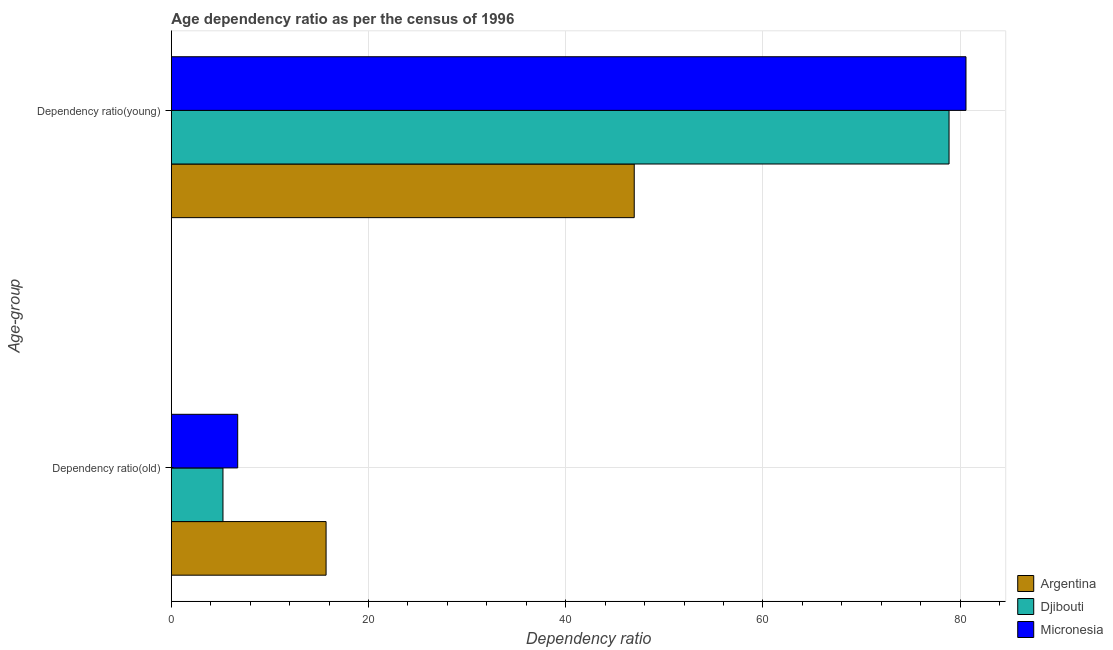How many different coloured bars are there?
Give a very brief answer. 3. Are the number of bars per tick equal to the number of legend labels?
Your response must be concise. Yes. Are the number of bars on each tick of the Y-axis equal?
Provide a short and direct response. Yes. How many bars are there on the 2nd tick from the top?
Keep it short and to the point. 3. How many bars are there on the 2nd tick from the bottom?
Provide a short and direct response. 3. What is the label of the 1st group of bars from the top?
Provide a succinct answer. Dependency ratio(young). What is the age dependency ratio(old) in Djibouti?
Provide a succinct answer. 5.23. Across all countries, what is the maximum age dependency ratio(young)?
Offer a very short reply. 80.6. Across all countries, what is the minimum age dependency ratio(young)?
Offer a very short reply. 46.95. In which country was the age dependency ratio(young) maximum?
Your answer should be very brief. Micronesia. In which country was the age dependency ratio(old) minimum?
Make the answer very short. Djibouti. What is the total age dependency ratio(young) in the graph?
Offer a very short reply. 206.44. What is the difference between the age dependency ratio(young) in Djibouti and that in Argentina?
Your answer should be very brief. 31.93. What is the difference between the age dependency ratio(young) in Argentina and the age dependency ratio(old) in Micronesia?
Offer a terse response. 40.22. What is the average age dependency ratio(young) per country?
Make the answer very short. 68.81. What is the difference between the age dependency ratio(old) and age dependency ratio(young) in Micronesia?
Your answer should be compact. -73.87. In how many countries, is the age dependency ratio(young) greater than 24 ?
Your answer should be very brief. 3. What is the ratio of the age dependency ratio(old) in Micronesia to that in Djibouti?
Provide a short and direct response. 1.29. Is the age dependency ratio(old) in Djibouti less than that in Micronesia?
Your response must be concise. Yes. In how many countries, is the age dependency ratio(old) greater than the average age dependency ratio(old) taken over all countries?
Give a very brief answer. 1. What does the 1st bar from the top in Dependency ratio(old) represents?
Offer a very short reply. Micronesia. How many bars are there?
Provide a succinct answer. 6. Does the graph contain any zero values?
Make the answer very short. No. Where does the legend appear in the graph?
Your response must be concise. Bottom right. How are the legend labels stacked?
Your answer should be very brief. Vertical. What is the title of the graph?
Offer a very short reply. Age dependency ratio as per the census of 1996. Does "Norway" appear as one of the legend labels in the graph?
Your answer should be compact. No. What is the label or title of the X-axis?
Ensure brevity in your answer.  Dependency ratio. What is the label or title of the Y-axis?
Your answer should be very brief. Age-group. What is the Dependency ratio of Argentina in Dependency ratio(old)?
Your answer should be compact. 15.69. What is the Dependency ratio in Djibouti in Dependency ratio(old)?
Make the answer very short. 5.23. What is the Dependency ratio in Micronesia in Dependency ratio(old)?
Keep it short and to the point. 6.73. What is the Dependency ratio of Argentina in Dependency ratio(young)?
Provide a short and direct response. 46.95. What is the Dependency ratio of Djibouti in Dependency ratio(young)?
Offer a terse response. 78.88. What is the Dependency ratio in Micronesia in Dependency ratio(young)?
Provide a short and direct response. 80.6. Across all Age-group, what is the maximum Dependency ratio of Argentina?
Your answer should be very brief. 46.95. Across all Age-group, what is the maximum Dependency ratio of Djibouti?
Provide a short and direct response. 78.88. Across all Age-group, what is the maximum Dependency ratio in Micronesia?
Give a very brief answer. 80.6. Across all Age-group, what is the minimum Dependency ratio in Argentina?
Give a very brief answer. 15.69. Across all Age-group, what is the minimum Dependency ratio in Djibouti?
Provide a succinct answer. 5.23. Across all Age-group, what is the minimum Dependency ratio in Micronesia?
Your answer should be compact. 6.73. What is the total Dependency ratio of Argentina in the graph?
Ensure brevity in your answer.  62.64. What is the total Dependency ratio in Djibouti in the graph?
Your answer should be compact. 84.12. What is the total Dependency ratio of Micronesia in the graph?
Your answer should be very brief. 87.33. What is the difference between the Dependency ratio in Argentina in Dependency ratio(old) and that in Dependency ratio(young)?
Provide a short and direct response. -31.26. What is the difference between the Dependency ratio of Djibouti in Dependency ratio(old) and that in Dependency ratio(young)?
Your answer should be very brief. -73.65. What is the difference between the Dependency ratio of Micronesia in Dependency ratio(old) and that in Dependency ratio(young)?
Keep it short and to the point. -73.87. What is the difference between the Dependency ratio of Argentina in Dependency ratio(old) and the Dependency ratio of Djibouti in Dependency ratio(young)?
Your answer should be compact. -63.19. What is the difference between the Dependency ratio of Argentina in Dependency ratio(old) and the Dependency ratio of Micronesia in Dependency ratio(young)?
Offer a terse response. -64.91. What is the difference between the Dependency ratio of Djibouti in Dependency ratio(old) and the Dependency ratio of Micronesia in Dependency ratio(young)?
Ensure brevity in your answer.  -75.37. What is the average Dependency ratio in Argentina per Age-group?
Ensure brevity in your answer.  31.32. What is the average Dependency ratio of Djibouti per Age-group?
Offer a terse response. 42.06. What is the average Dependency ratio in Micronesia per Age-group?
Your answer should be very brief. 43.66. What is the difference between the Dependency ratio of Argentina and Dependency ratio of Djibouti in Dependency ratio(old)?
Provide a short and direct response. 10.46. What is the difference between the Dependency ratio of Argentina and Dependency ratio of Micronesia in Dependency ratio(old)?
Ensure brevity in your answer.  8.96. What is the difference between the Dependency ratio in Djibouti and Dependency ratio in Micronesia in Dependency ratio(old)?
Your answer should be compact. -1.49. What is the difference between the Dependency ratio in Argentina and Dependency ratio in Djibouti in Dependency ratio(young)?
Keep it short and to the point. -31.93. What is the difference between the Dependency ratio of Argentina and Dependency ratio of Micronesia in Dependency ratio(young)?
Ensure brevity in your answer.  -33.65. What is the difference between the Dependency ratio of Djibouti and Dependency ratio of Micronesia in Dependency ratio(young)?
Your answer should be very brief. -1.72. What is the ratio of the Dependency ratio of Argentina in Dependency ratio(old) to that in Dependency ratio(young)?
Make the answer very short. 0.33. What is the ratio of the Dependency ratio of Djibouti in Dependency ratio(old) to that in Dependency ratio(young)?
Provide a short and direct response. 0.07. What is the ratio of the Dependency ratio of Micronesia in Dependency ratio(old) to that in Dependency ratio(young)?
Offer a terse response. 0.08. What is the difference between the highest and the second highest Dependency ratio of Argentina?
Ensure brevity in your answer.  31.26. What is the difference between the highest and the second highest Dependency ratio in Djibouti?
Offer a very short reply. 73.65. What is the difference between the highest and the second highest Dependency ratio in Micronesia?
Your answer should be compact. 73.87. What is the difference between the highest and the lowest Dependency ratio of Argentina?
Provide a short and direct response. 31.26. What is the difference between the highest and the lowest Dependency ratio of Djibouti?
Offer a very short reply. 73.65. What is the difference between the highest and the lowest Dependency ratio of Micronesia?
Offer a terse response. 73.87. 